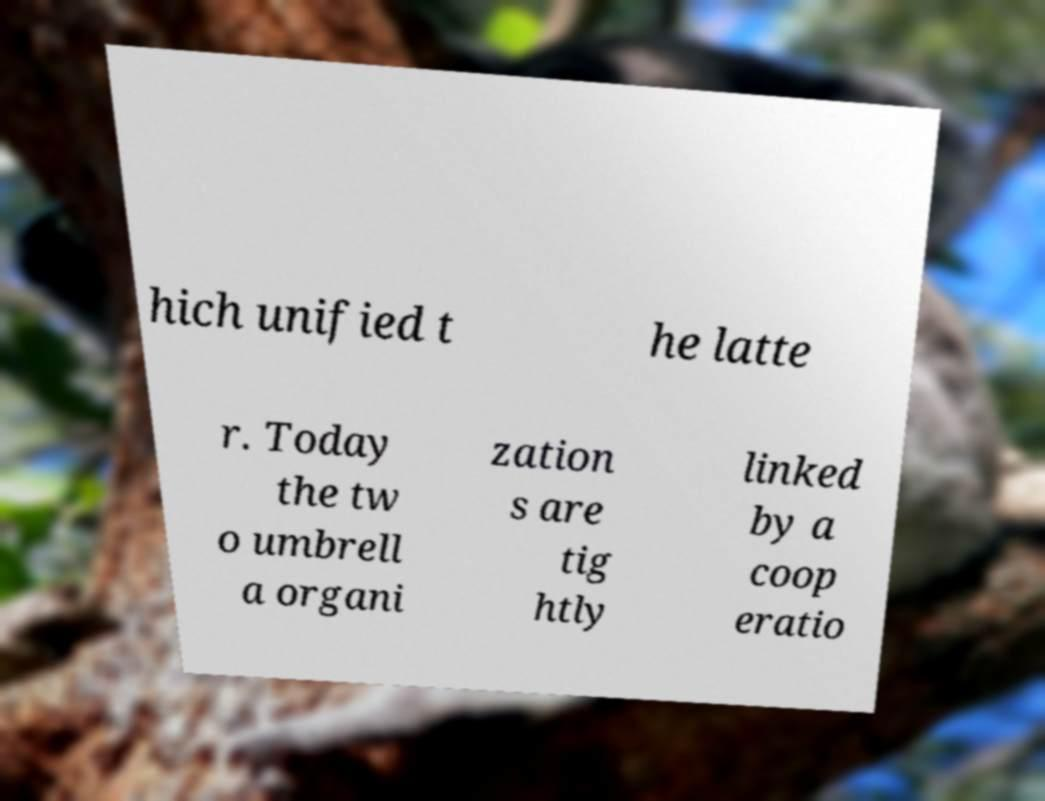Could you extract and type out the text from this image? hich unified t he latte r. Today the tw o umbrell a organi zation s are tig htly linked by a coop eratio 